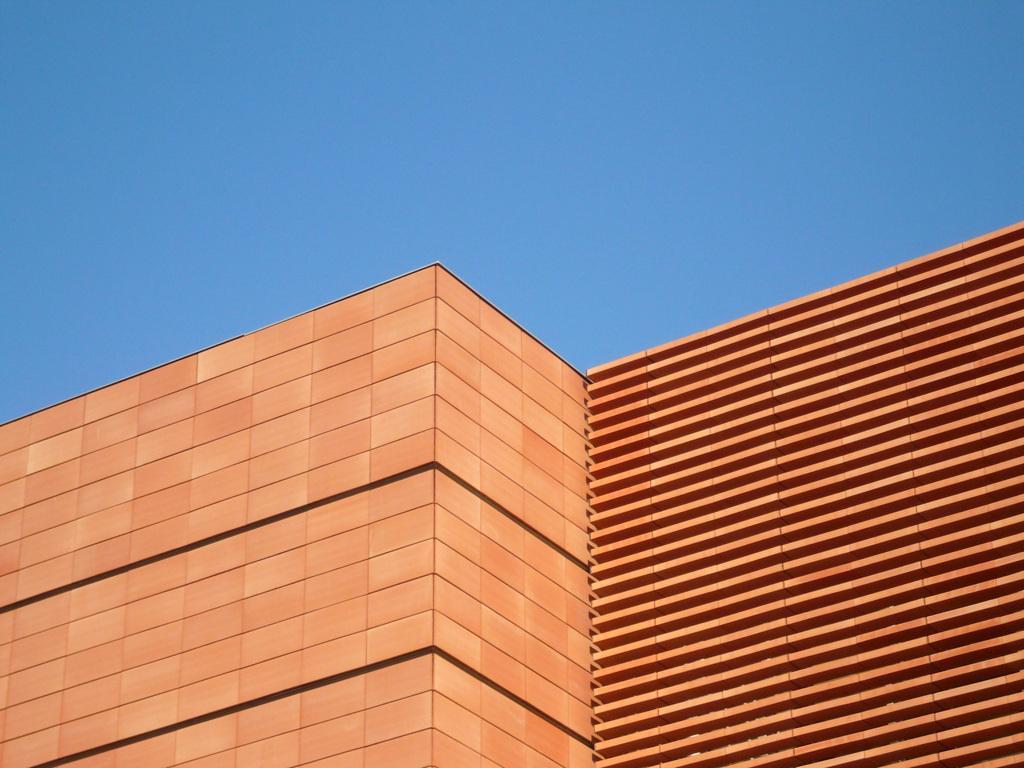Can you describe this image briefly? In this picture we can see building, which is orange and black in color. 